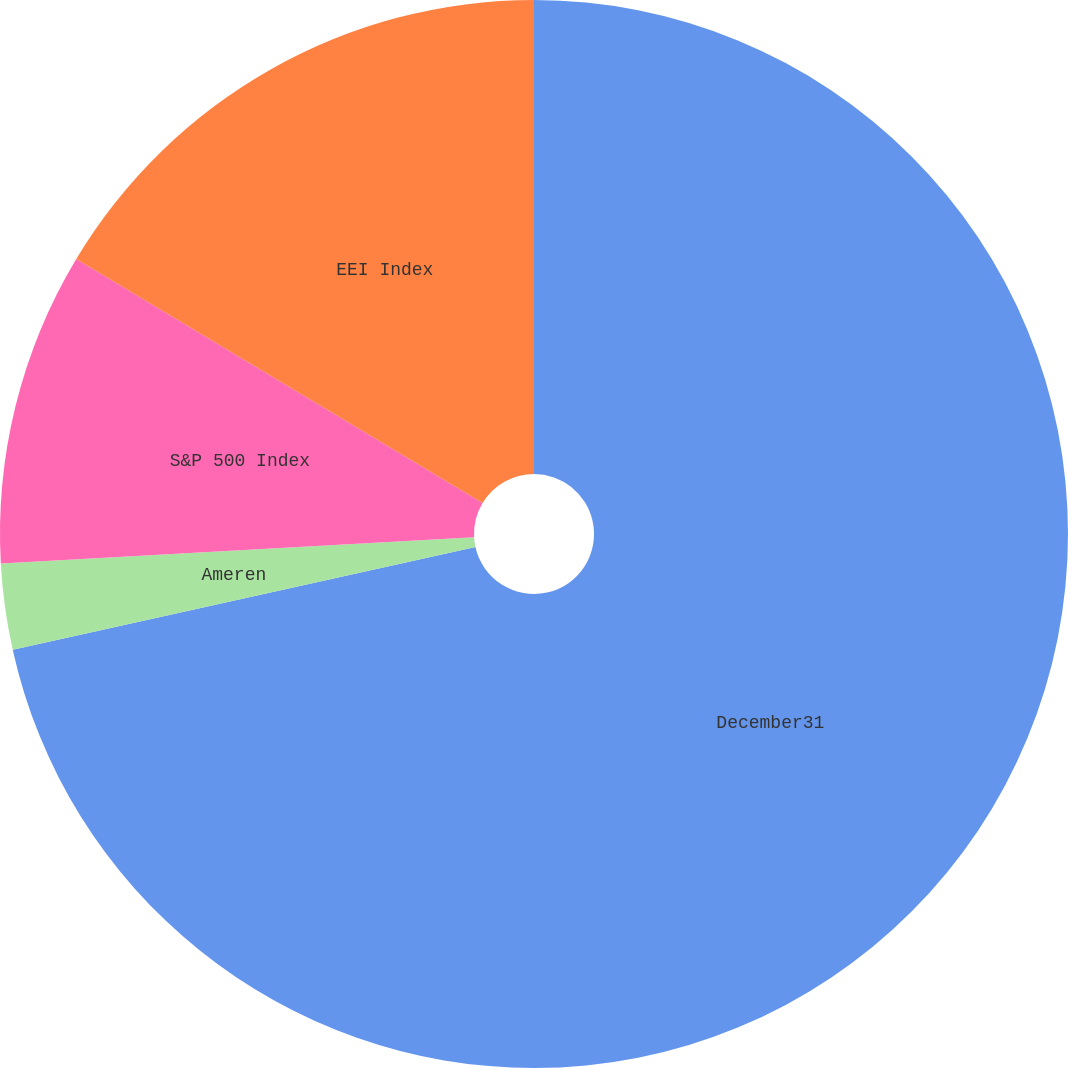Convert chart. <chart><loc_0><loc_0><loc_500><loc_500><pie_chart><fcel>December31<fcel>Ameren<fcel>S&P 500 Index<fcel>EEI Index<nl><fcel>71.52%<fcel>2.6%<fcel>9.49%<fcel>16.39%<nl></chart> 